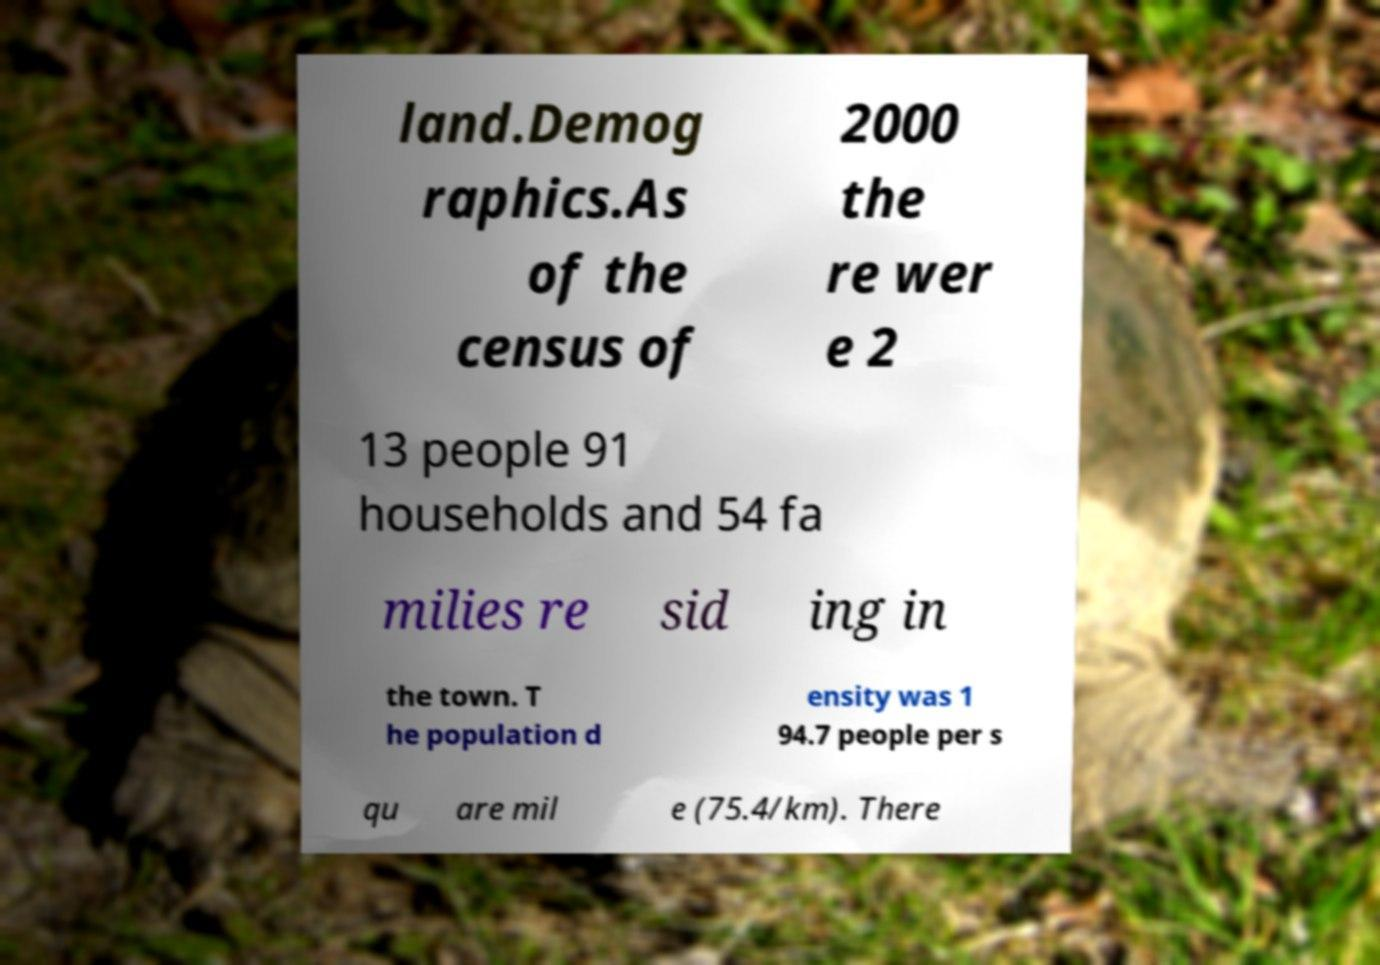Could you extract and type out the text from this image? land.Demog raphics.As of the census of 2000 the re wer e 2 13 people 91 households and 54 fa milies re sid ing in the town. T he population d ensity was 1 94.7 people per s qu are mil e (75.4/km). There 